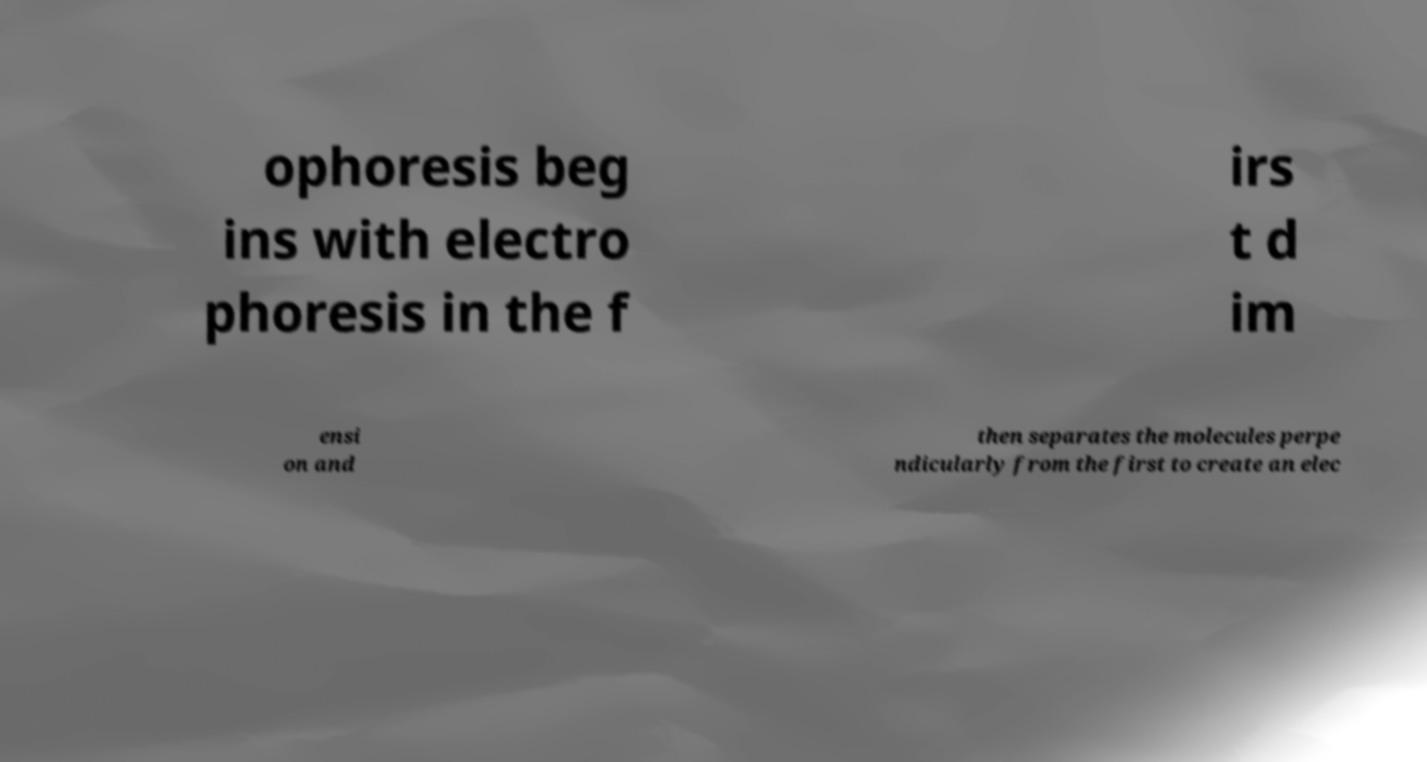Can you accurately transcribe the text from the provided image for me? ophoresis beg ins with electro phoresis in the f irs t d im ensi on and then separates the molecules perpe ndicularly from the first to create an elec 